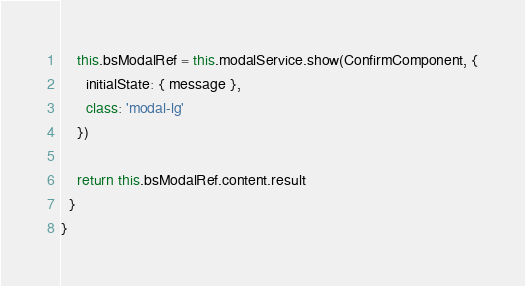<code> <loc_0><loc_0><loc_500><loc_500><_TypeScript_>    this.bsModalRef = this.modalService.show(ConfirmComponent, {
      initialState: { message },
      class: 'modal-lg'
    })

    return this.bsModalRef.content.result
  }
}
</code> 